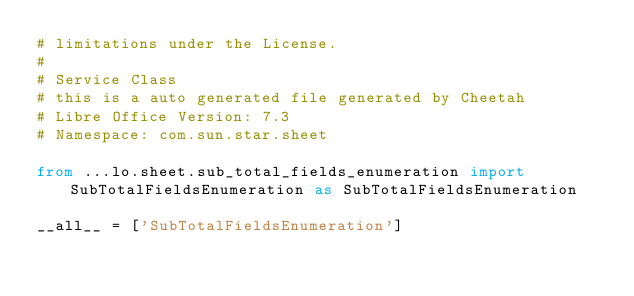<code> <loc_0><loc_0><loc_500><loc_500><_Python_># limitations under the License.
#
# Service Class
# this is a auto generated file generated by Cheetah
# Libre Office Version: 7.3
# Namespace: com.sun.star.sheet

from ...lo.sheet.sub_total_fields_enumeration import SubTotalFieldsEnumeration as SubTotalFieldsEnumeration

__all__ = ['SubTotalFieldsEnumeration']

</code> 